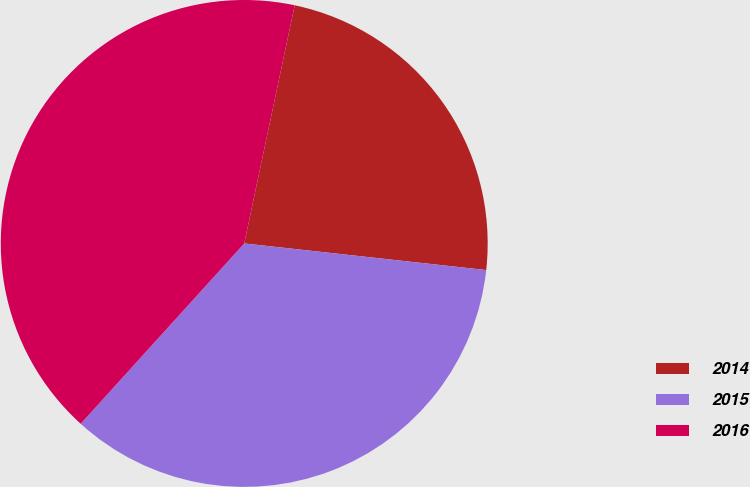Convert chart. <chart><loc_0><loc_0><loc_500><loc_500><pie_chart><fcel>2014<fcel>2015<fcel>2016<nl><fcel>23.42%<fcel>34.98%<fcel>41.6%<nl></chart> 